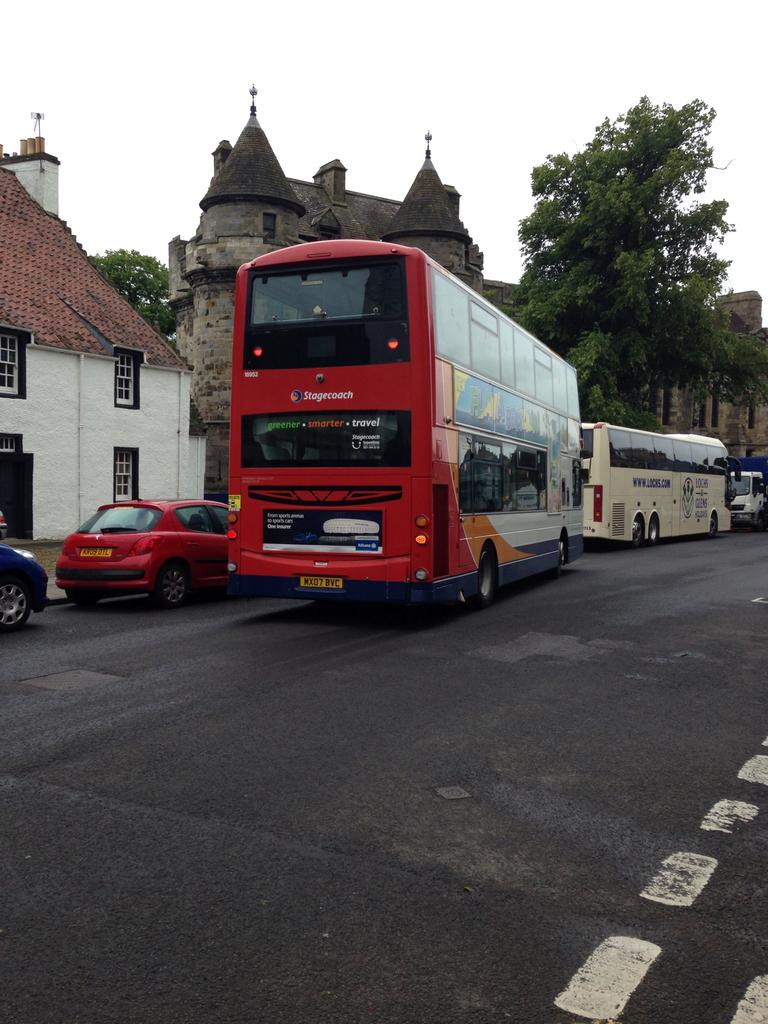<image>
Render a clear and concise summary of the photo. A red Stagecoach double-decker bus waits in traffic. 